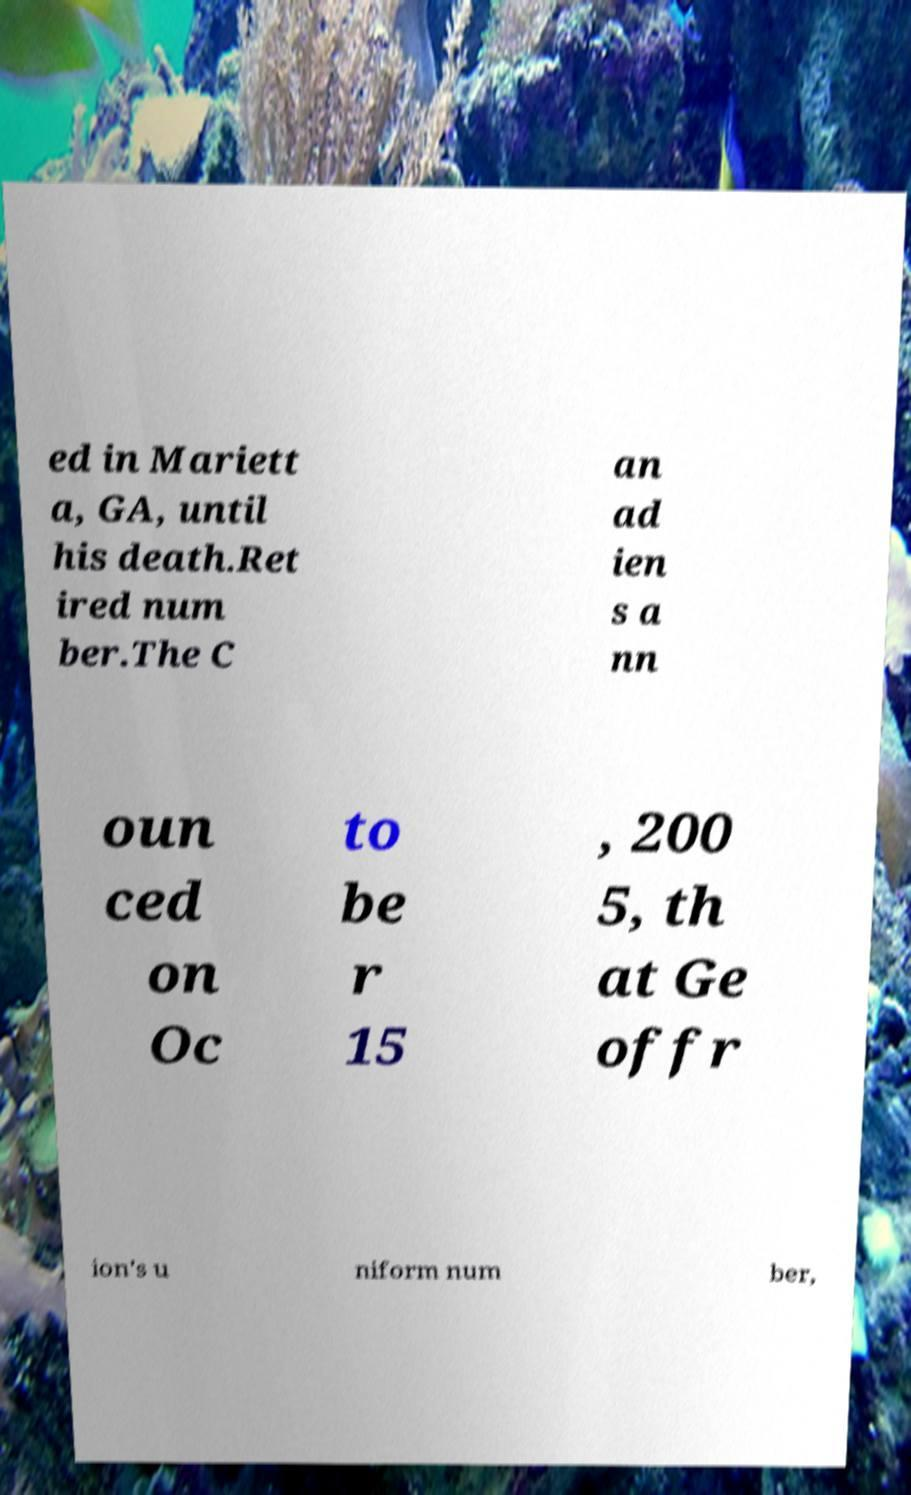Please identify and transcribe the text found in this image. ed in Mariett a, GA, until his death.Ret ired num ber.The C an ad ien s a nn oun ced on Oc to be r 15 , 200 5, th at Ge offr ion's u niform num ber, 